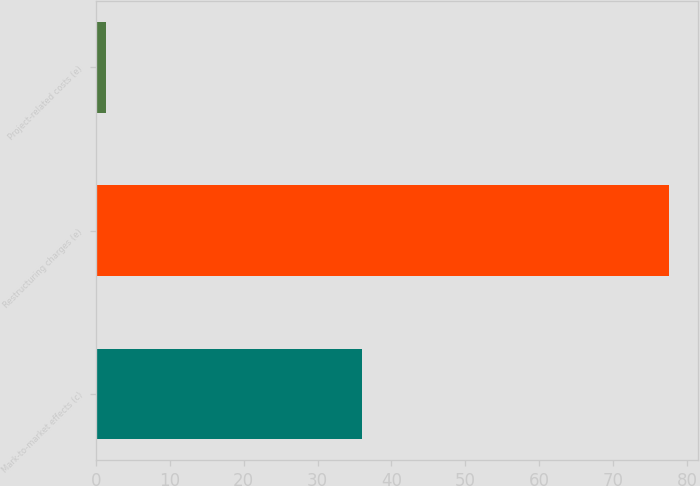<chart> <loc_0><loc_0><loc_500><loc_500><bar_chart><fcel>Mark-to-market effects (c)<fcel>Restructuring charges (e)<fcel>Project-related costs (e)<nl><fcel>36<fcel>77.6<fcel>1.3<nl></chart> 